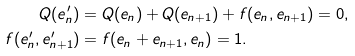<formula> <loc_0><loc_0><loc_500><loc_500>Q ( e _ { n } ^ { \prime } ) & = Q ( e _ { n } ) + Q ( e _ { n + 1 } ) + f ( e _ { n } , e _ { n + 1 } ) = 0 , \\ f ( e _ { n } ^ { \prime } , e ^ { \prime } _ { n + 1 } ) & = f ( e _ { n } + e _ { n + 1 } , e _ { n } ) = 1 .</formula> 